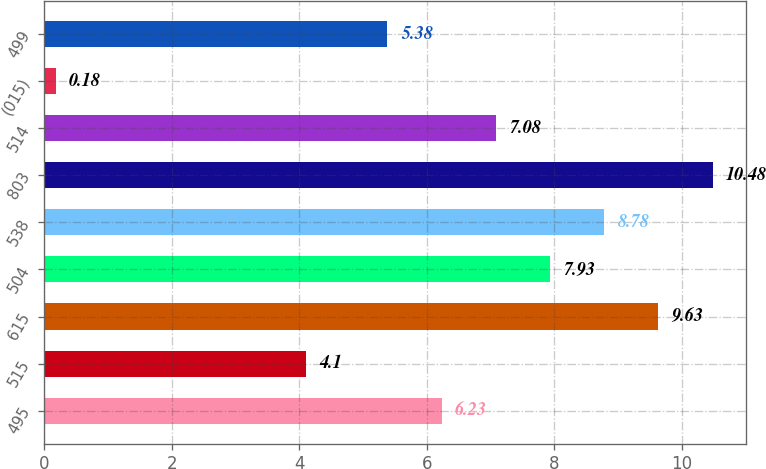Convert chart to OTSL. <chart><loc_0><loc_0><loc_500><loc_500><bar_chart><fcel>495<fcel>515<fcel>615<fcel>504<fcel>538<fcel>803<fcel>514<fcel>(015)<fcel>499<nl><fcel>6.23<fcel>4.1<fcel>9.63<fcel>7.93<fcel>8.78<fcel>10.48<fcel>7.08<fcel>0.18<fcel>5.38<nl></chart> 